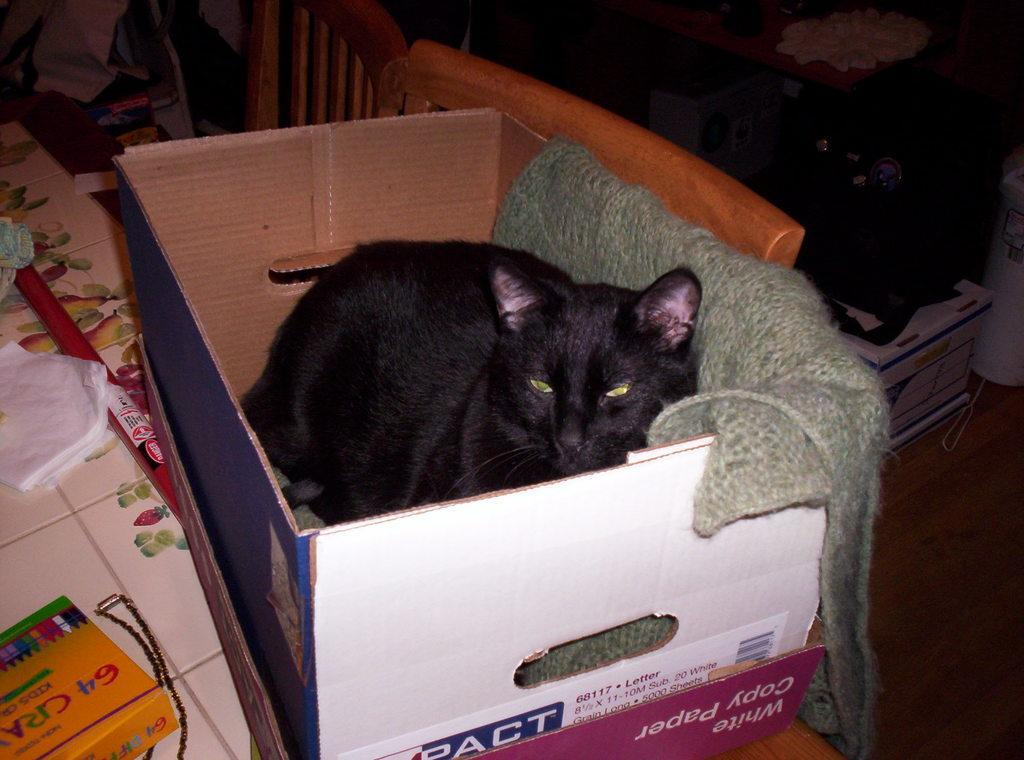Provide a one-sentence caption for the provided image. A cat lays in a box that used to contain white copy paper. 